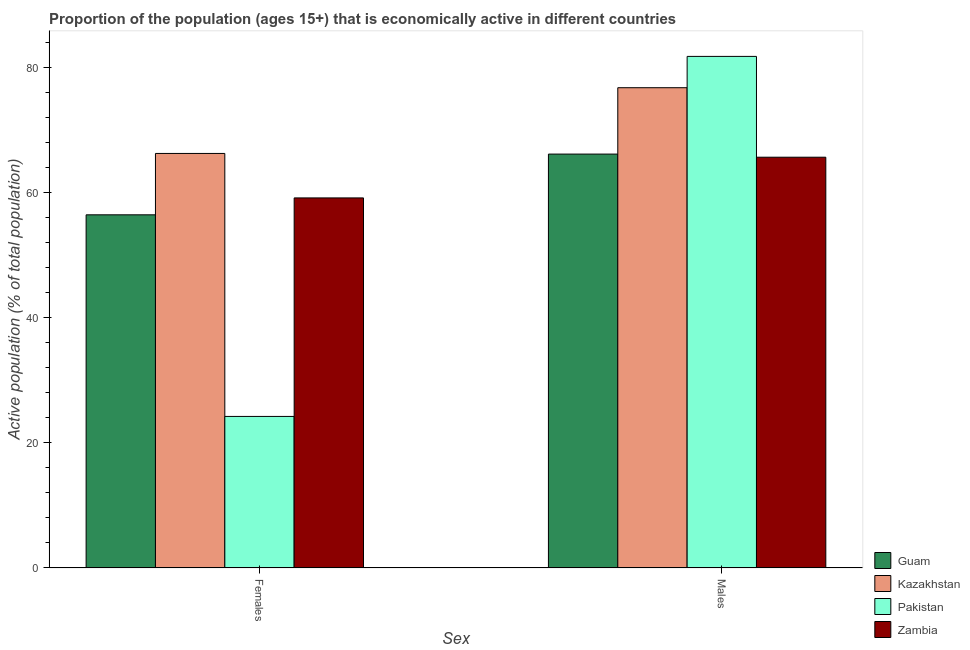How many different coloured bars are there?
Ensure brevity in your answer.  4. How many bars are there on the 1st tick from the left?
Your answer should be very brief. 4. What is the label of the 2nd group of bars from the left?
Your answer should be very brief. Males. What is the percentage of economically active male population in Kazakhstan?
Offer a very short reply. 76.7. Across all countries, what is the maximum percentage of economically active female population?
Provide a short and direct response. 66.2. Across all countries, what is the minimum percentage of economically active female population?
Your response must be concise. 24.2. In which country was the percentage of economically active female population maximum?
Provide a short and direct response. Kazakhstan. What is the total percentage of economically active female population in the graph?
Your response must be concise. 205.9. What is the difference between the percentage of economically active male population in Kazakhstan and that in Guam?
Your answer should be compact. 10.6. What is the difference between the percentage of economically active female population in Pakistan and the percentage of economically active male population in Guam?
Offer a very short reply. -41.9. What is the average percentage of economically active male population per country?
Provide a short and direct response. 72.52. What is the difference between the percentage of economically active female population and percentage of economically active male population in Kazakhstan?
Offer a terse response. -10.5. What is the ratio of the percentage of economically active male population in Pakistan to that in Kazakhstan?
Offer a terse response. 1.07. What does the 1st bar from the left in Males represents?
Your answer should be compact. Guam. What does the 1st bar from the right in Males represents?
Offer a very short reply. Zambia. How many bars are there?
Your answer should be compact. 8. Are all the bars in the graph horizontal?
Your response must be concise. No. Does the graph contain any zero values?
Your answer should be compact. No. Does the graph contain grids?
Your answer should be compact. No. Where does the legend appear in the graph?
Provide a succinct answer. Bottom right. What is the title of the graph?
Provide a short and direct response. Proportion of the population (ages 15+) that is economically active in different countries. What is the label or title of the X-axis?
Provide a short and direct response. Sex. What is the label or title of the Y-axis?
Keep it short and to the point. Active population (% of total population). What is the Active population (% of total population) of Guam in Females?
Your answer should be compact. 56.4. What is the Active population (% of total population) in Kazakhstan in Females?
Keep it short and to the point. 66.2. What is the Active population (% of total population) in Pakistan in Females?
Provide a succinct answer. 24.2. What is the Active population (% of total population) of Zambia in Females?
Your response must be concise. 59.1. What is the Active population (% of total population) in Guam in Males?
Offer a very short reply. 66.1. What is the Active population (% of total population) in Kazakhstan in Males?
Your response must be concise. 76.7. What is the Active population (% of total population) in Pakistan in Males?
Offer a terse response. 81.7. What is the Active population (% of total population) in Zambia in Males?
Keep it short and to the point. 65.6. Across all Sex, what is the maximum Active population (% of total population) of Guam?
Provide a short and direct response. 66.1. Across all Sex, what is the maximum Active population (% of total population) of Kazakhstan?
Your answer should be very brief. 76.7. Across all Sex, what is the maximum Active population (% of total population) in Pakistan?
Provide a succinct answer. 81.7. Across all Sex, what is the maximum Active population (% of total population) of Zambia?
Keep it short and to the point. 65.6. Across all Sex, what is the minimum Active population (% of total population) of Guam?
Offer a very short reply. 56.4. Across all Sex, what is the minimum Active population (% of total population) in Kazakhstan?
Ensure brevity in your answer.  66.2. Across all Sex, what is the minimum Active population (% of total population) of Pakistan?
Keep it short and to the point. 24.2. Across all Sex, what is the minimum Active population (% of total population) in Zambia?
Provide a short and direct response. 59.1. What is the total Active population (% of total population) in Guam in the graph?
Your answer should be very brief. 122.5. What is the total Active population (% of total population) in Kazakhstan in the graph?
Offer a terse response. 142.9. What is the total Active population (% of total population) in Pakistan in the graph?
Give a very brief answer. 105.9. What is the total Active population (% of total population) of Zambia in the graph?
Your response must be concise. 124.7. What is the difference between the Active population (% of total population) in Kazakhstan in Females and that in Males?
Ensure brevity in your answer.  -10.5. What is the difference between the Active population (% of total population) in Pakistan in Females and that in Males?
Your answer should be very brief. -57.5. What is the difference between the Active population (% of total population) in Guam in Females and the Active population (% of total population) in Kazakhstan in Males?
Provide a succinct answer. -20.3. What is the difference between the Active population (% of total population) of Guam in Females and the Active population (% of total population) of Pakistan in Males?
Make the answer very short. -25.3. What is the difference between the Active population (% of total population) of Kazakhstan in Females and the Active population (% of total population) of Pakistan in Males?
Your answer should be very brief. -15.5. What is the difference between the Active population (% of total population) in Pakistan in Females and the Active population (% of total population) in Zambia in Males?
Offer a terse response. -41.4. What is the average Active population (% of total population) of Guam per Sex?
Keep it short and to the point. 61.25. What is the average Active population (% of total population) of Kazakhstan per Sex?
Give a very brief answer. 71.45. What is the average Active population (% of total population) in Pakistan per Sex?
Offer a very short reply. 52.95. What is the average Active population (% of total population) in Zambia per Sex?
Make the answer very short. 62.35. What is the difference between the Active population (% of total population) of Guam and Active population (% of total population) of Pakistan in Females?
Make the answer very short. 32.2. What is the difference between the Active population (% of total population) of Guam and Active population (% of total population) of Zambia in Females?
Give a very brief answer. -2.7. What is the difference between the Active population (% of total population) of Kazakhstan and Active population (% of total population) of Zambia in Females?
Offer a terse response. 7.1. What is the difference between the Active population (% of total population) of Pakistan and Active population (% of total population) of Zambia in Females?
Your response must be concise. -34.9. What is the difference between the Active population (% of total population) in Guam and Active population (% of total population) in Pakistan in Males?
Give a very brief answer. -15.6. What is the difference between the Active population (% of total population) of Guam and Active population (% of total population) of Zambia in Males?
Make the answer very short. 0.5. What is the difference between the Active population (% of total population) of Kazakhstan and Active population (% of total population) of Pakistan in Males?
Provide a short and direct response. -5. What is the difference between the Active population (% of total population) of Pakistan and Active population (% of total population) of Zambia in Males?
Your answer should be very brief. 16.1. What is the ratio of the Active population (% of total population) of Guam in Females to that in Males?
Your answer should be very brief. 0.85. What is the ratio of the Active population (% of total population) of Kazakhstan in Females to that in Males?
Make the answer very short. 0.86. What is the ratio of the Active population (% of total population) in Pakistan in Females to that in Males?
Give a very brief answer. 0.3. What is the ratio of the Active population (% of total population) in Zambia in Females to that in Males?
Offer a very short reply. 0.9. What is the difference between the highest and the second highest Active population (% of total population) in Pakistan?
Provide a succinct answer. 57.5. What is the difference between the highest and the lowest Active population (% of total population) in Guam?
Give a very brief answer. 9.7. What is the difference between the highest and the lowest Active population (% of total population) in Kazakhstan?
Provide a succinct answer. 10.5. What is the difference between the highest and the lowest Active population (% of total population) in Pakistan?
Your answer should be compact. 57.5. What is the difference between the highest and the lowest Active population (% of total population) of Zambia?
Your response must be concise. 6.5. 